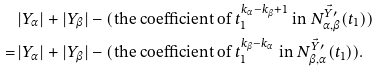<formula> <loc_0><loc_0><loc_500><loc_500>& | Y _ { \alpha } | + | Y _ { \beta } | - ( \text {the coefficient of $t_{1}^{k_{\alpha}-k_{\beta}+1}$    in $N^{\vec{Y}\prime}_{\alpha,\beta}(t_{1})$} ) \\ = \, & | Y _ { \alpha } | + | Y _ { \beta } | - ( \text {the coefficient of $t_{1}^{k_{\beta} - k_{\alpha}}$    in $N^{\vec{Y}\prime}_{\beta,\alpha}(t_{1})$} ) .</formula> 